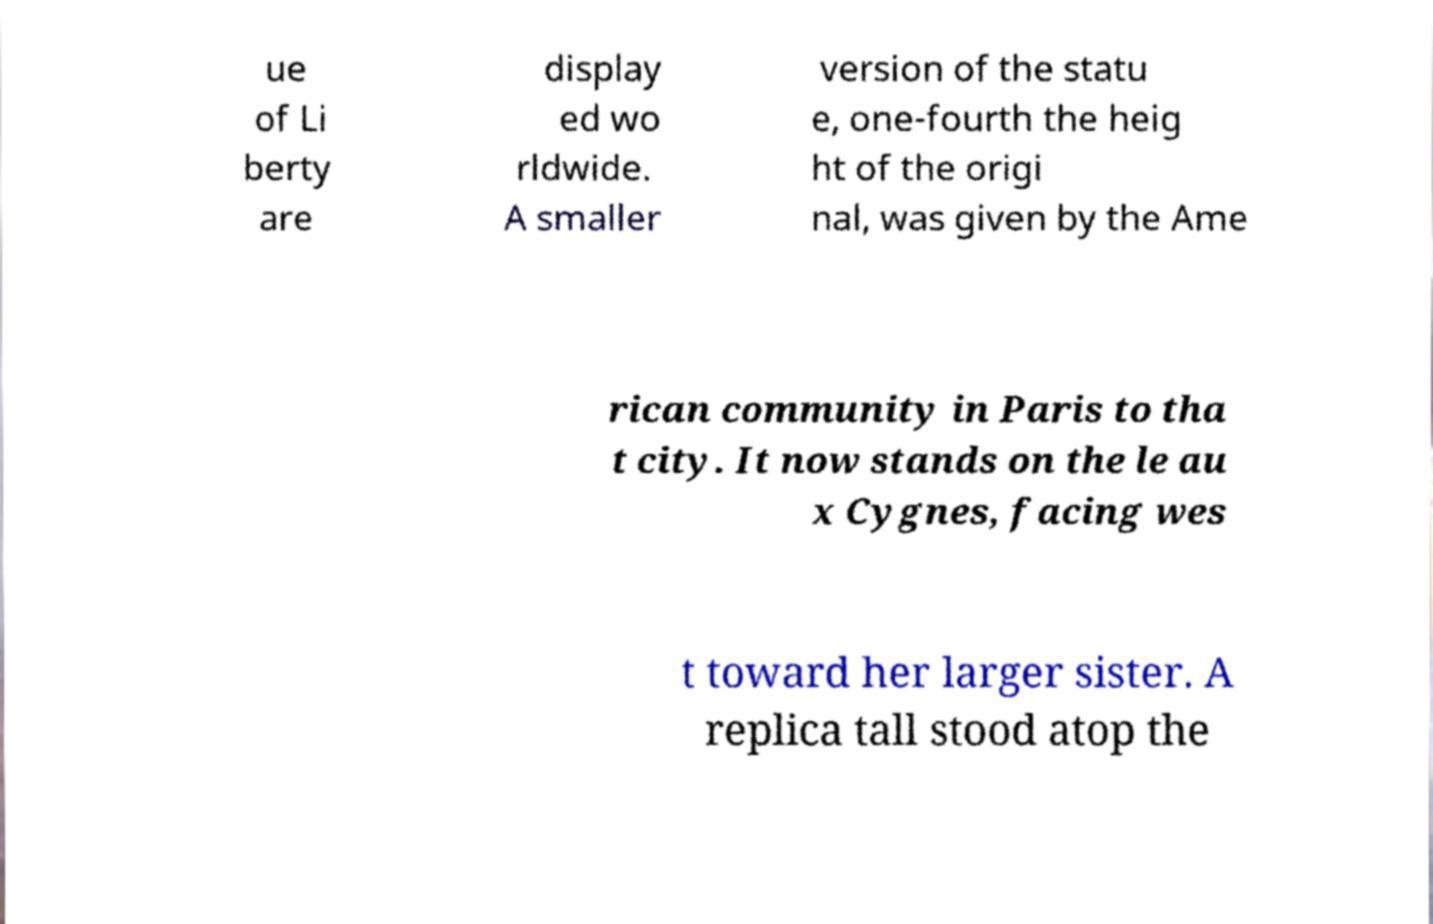There's text embedded in this image that I need extracted. Can you transcribe it verbatim? ue of Li berty are display ed wo rldwide. A smaller version of the statu e, one-fourth the heig ht of the origi nal, was given by the Ame rican community in Paris to tha t city. It now stands on the le au x Cygnes, facing wes t toward her larger sister. A replica tall stood atop the 